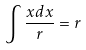Convert formula to latex. <formula><loc_0><loc_0><loc_500><loc_500>\int \frac { x d x } { r } = r</formula> 